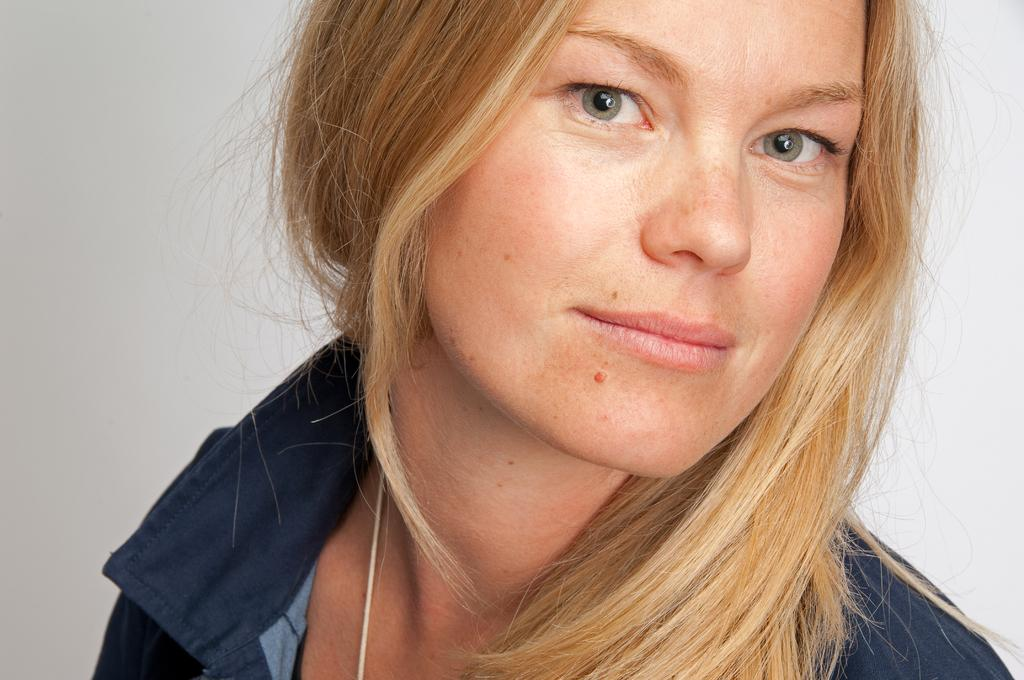What is the main subject of the image? The main subject of the image is a woman. What is the woman wearing in the image? The woman is wearing a shirt. What can be seen in the background of the image? There is a wall in the background of the image. How many rooms can be seen in the image? There is no room visible in the image; it only features a woman and a wall in the background. How many women are present in the image? There is only one woman present in the image. 